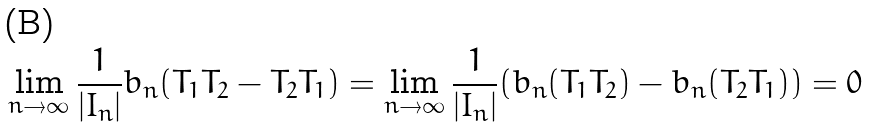<formula> <loc_0><loc_0><loc_500><loc_500>\lim _ { n \rightarrow \infty } \frac { 1 } { | I _ { n } | } b _ { n } ( T _ { 1 } T _ { 2 } - T _ { 2 } T _ { 1 } ) = \lim _ { n \rightarrow \infty } \frac { 1 } { | I _ { n } | } ( b _ { n } ( T _ { 1 } T _ { 2 } ) - b _ { n } ( T _ { 2 } T _ { 1 } ) ) = 0</formula> 